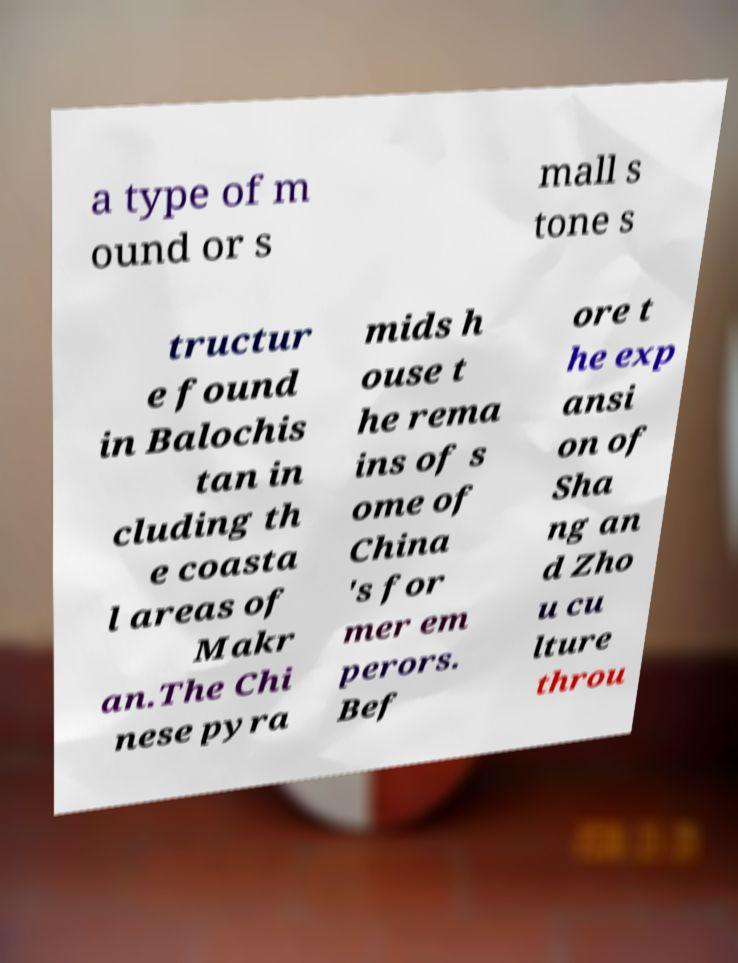Can you accurately transcribe the text from the provided image for me? a type of m ound or s mall s tone s tructur e found in Balochis tan in cluding th e coasta l areas of Makr an.The Chi nese pyra mids h ouse t he rema ins of s ome of China 's for mer em perors. Bef ore t he exp ansi on of Sha ng an d Zho u cu lture throu 